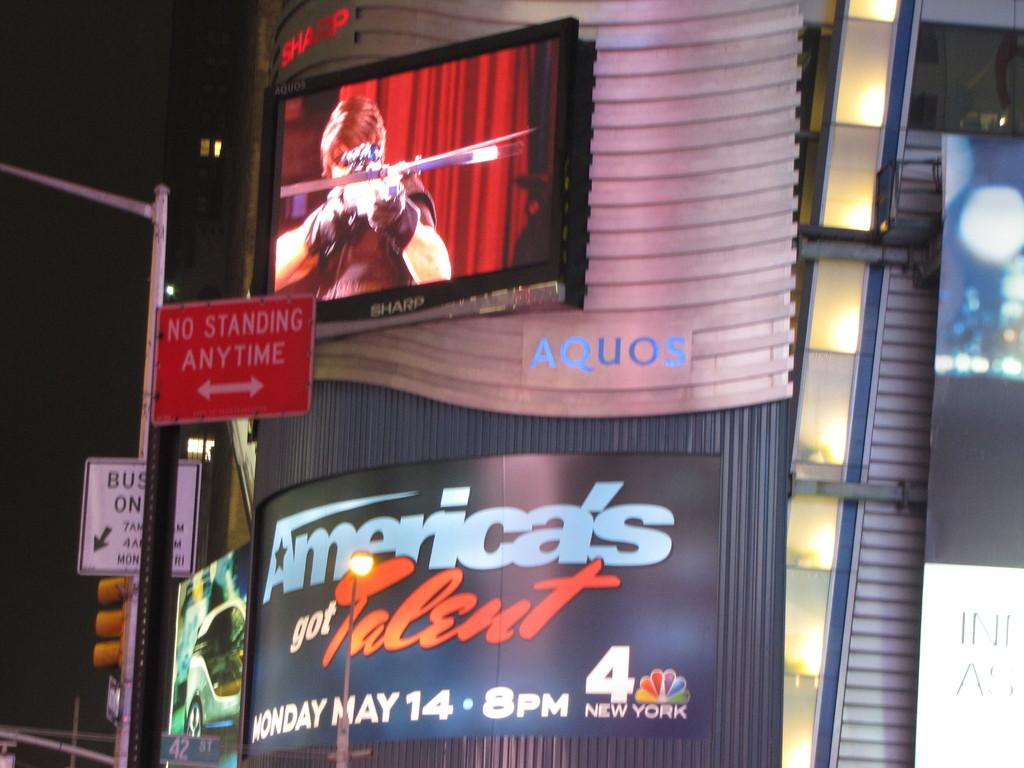<image>
Write a terse but informative summary of the picture. A LITE MARQUE ON THE STREET OF AMERICAS GOT TALET 